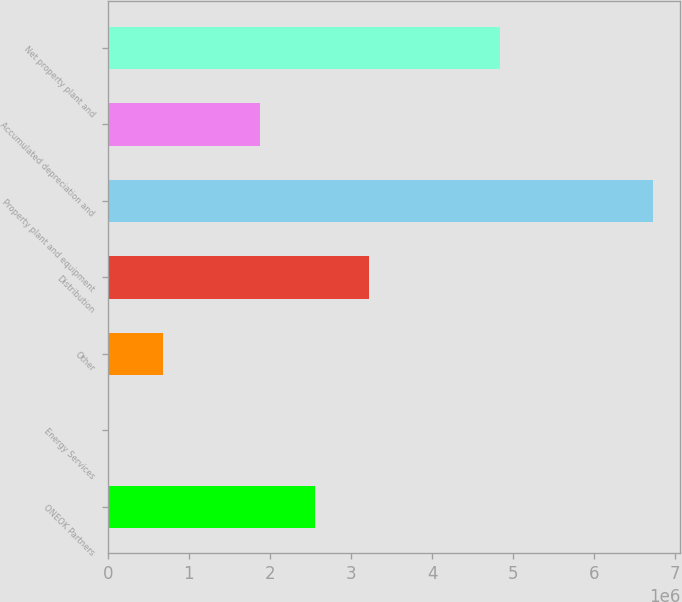<chart> <loc_0><loc_0><loc_500><loc_500><bar_chart><fcel>ONEOK Partners<fcel>Energy Services<fcel>Other<fcel>Distribution<fcel>Property plant and equipment<fcel>Accumulated depreciation and<fcel>Net property plant and<nl><fcel>2.55154e+06<fcel>7689<fcel>679396<fcel>3.22325e+06<fcel>6.72476e+06<fcel>1.87984e+06<fcel>4.84492e+06<nl></chart> 